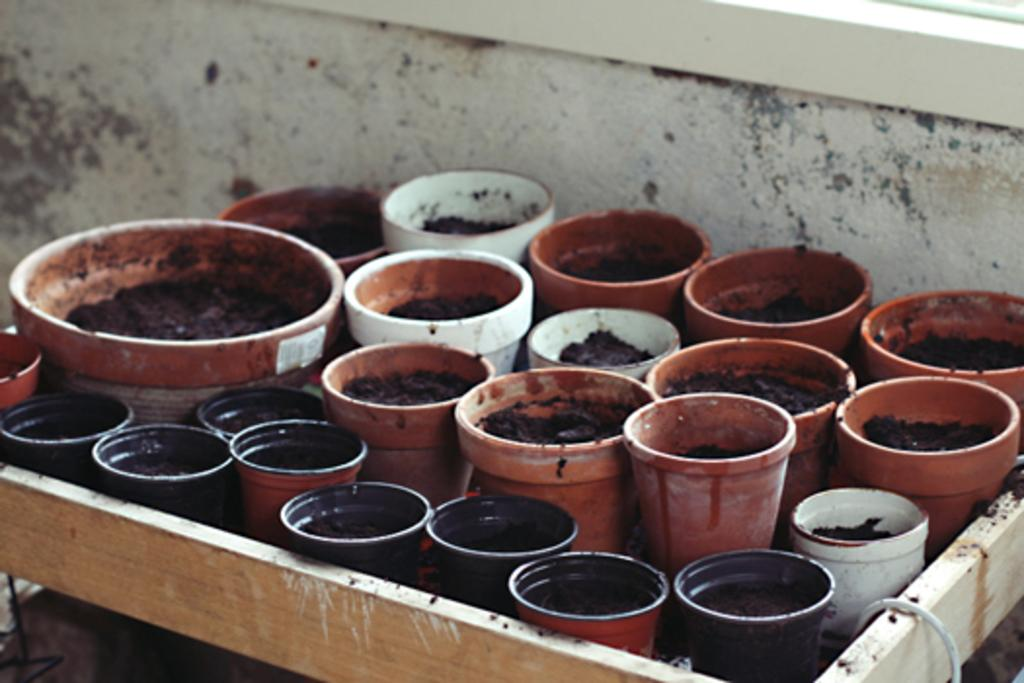What objects are present in the image? There are flower pots in the image. What can be seen in the background of the image? There is a wall in the background of the image. What type of government is depicted in the image? There is no depiction of a government in the image; it features flower pots and a wall. How many feet are visible in the image? There are no feet visible in the image. 